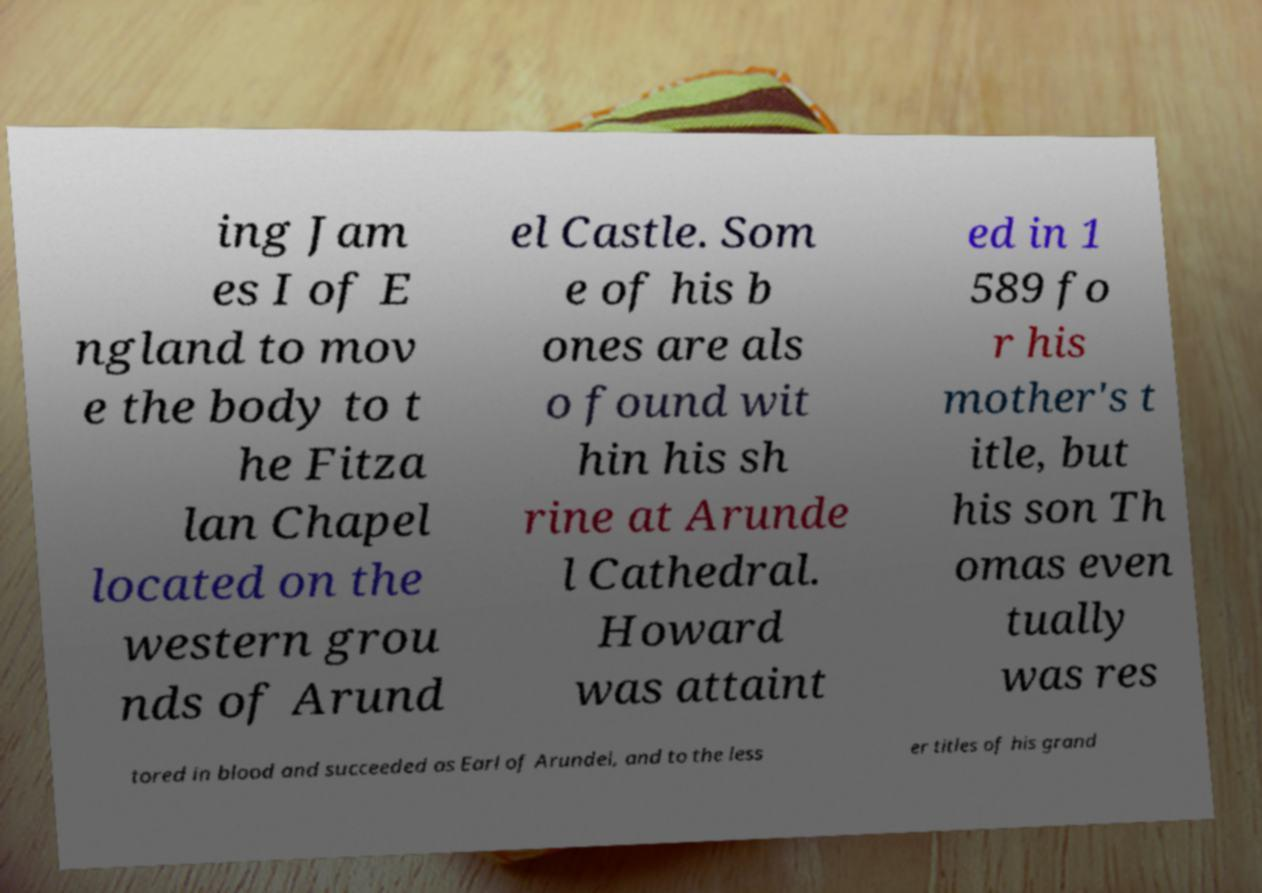What messages or text are displayed in this image? I need them in a readable, typed format. ing Jam es I of E ngland to mov e the body to t he Fitza lan Chapel located on the western grou nds of Arund el Castle. Som e of his b ones are als o found wit hin his sh rine at Arunde l Cathedral. Howard was attaint ed in 1 589 fo r his mother's t itle, but his son Th omas even tually was res tored in blood and succeeded as Earl of Arundel, and to the less er titles of his grand 